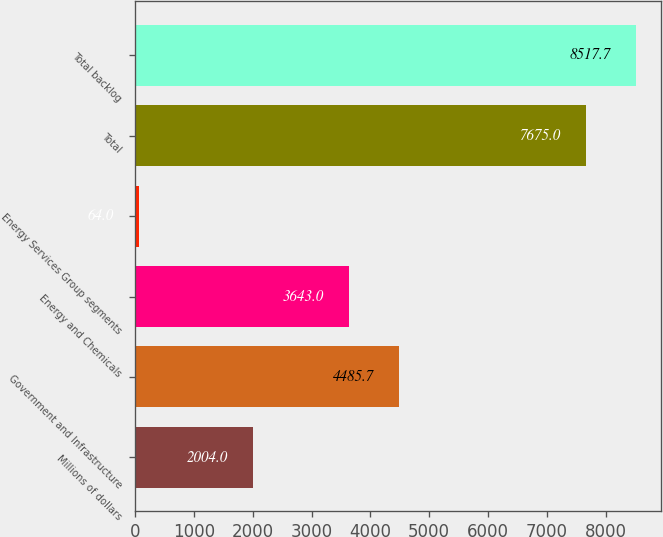<chart> <loc_0><loc_0><loc_500><loc_500><bar_chart><fcel>Millions of dollars<fcel>Government and Infrastructure<fcel>Energy and Chemicals<fcel>Energy Services Group segments<fcel>Total<fcel>Total backlog<nl><fcel>2004<fcel>4485.7<fcel>3643<fcel>64<fcel>7675<fcel>8517.7<nl></chart> 